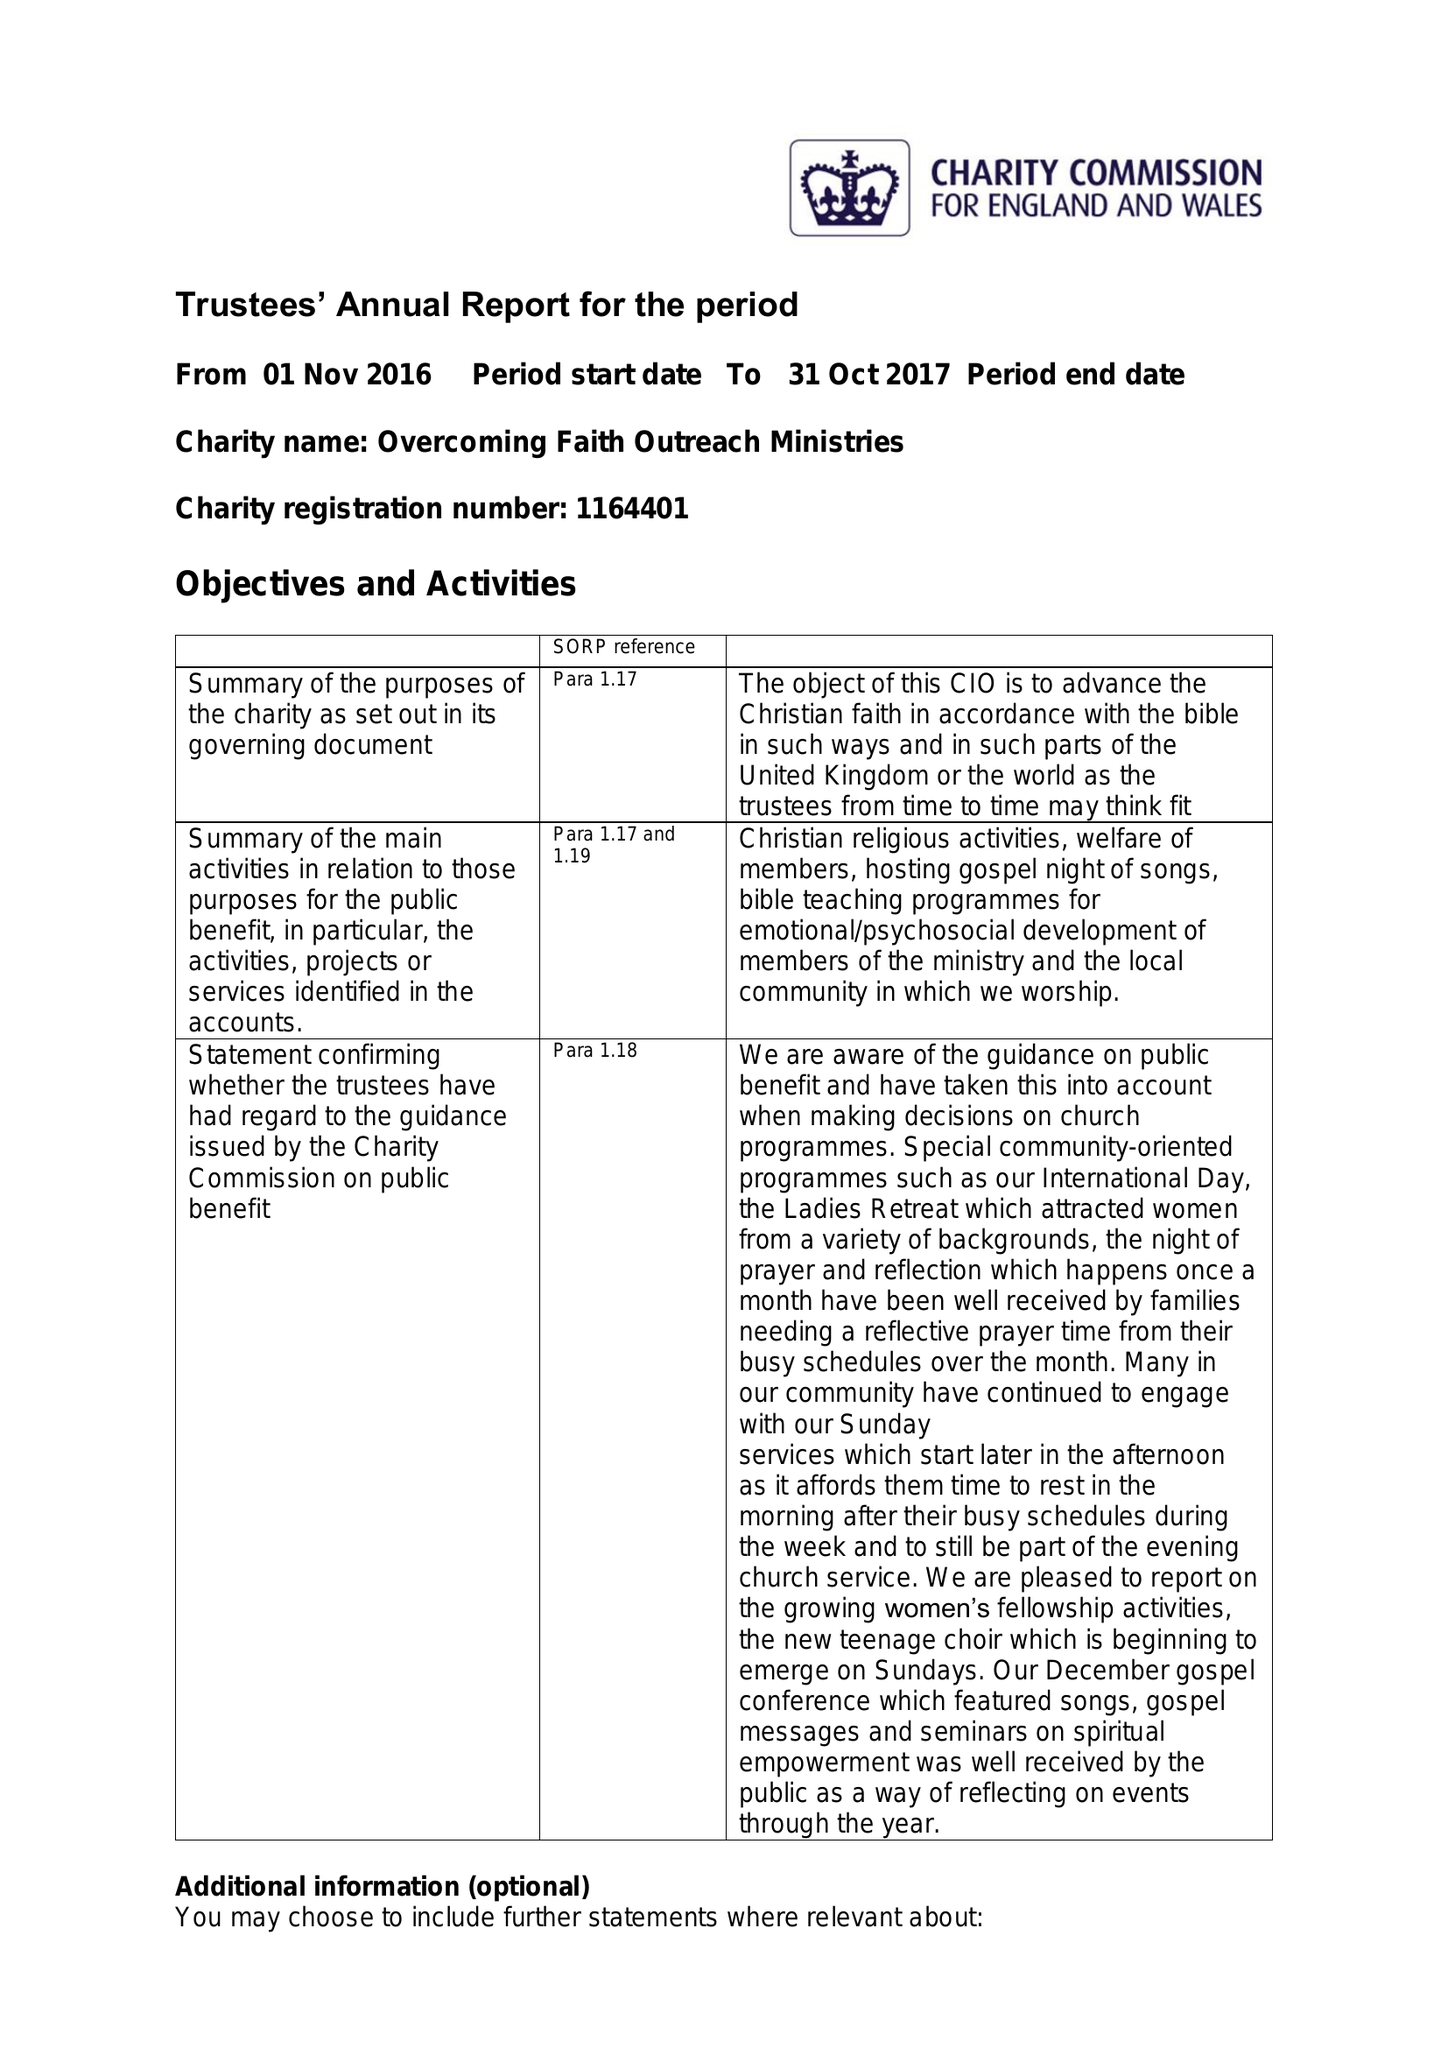What is the value for the address__street_line?
Answer the question using a single word or phrase. None 